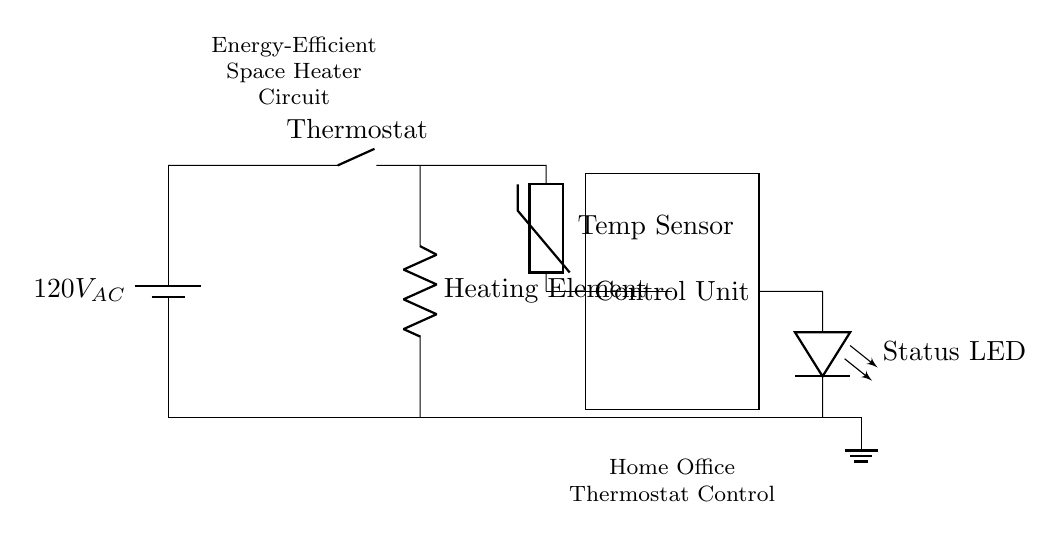What is the main power supply voltage of this circuit? The power supply voltage is indicated as 120V AC, which is explicitly shown at the start of the circuit diagram.
Answer: 120V AC What component acts as the control mechanism in this circuit? The control mechanism in this circuit is the control unit, which is a rectangular box labeled "Control Unit" connected to other components for regulating the heater's operation.
Answer: Control Unit What is the function of the thermistor in the circuit? The thermistor serves as a temperature sensor, measuring the ambient temperature and providing input to the control unit based on that measurement to regulate the heating element.
Answer: Temperature sensor How is the heating element connected in the circuit? The heating element is connected in series to the power supply and the thermostat, indicating that it is involved in the direct heating of the space once the thermostat allows current to flow.
Answer: In series with the power supply and thermostat What type of indicator is used in this circuit? The indicator used in this circuit is an LED, which is represented in the diagram as "Status LED". It shows the operational status of the space heater.
Answer: LED Which component is responsible for executing the heating regulation based on temperature? The component responsible for executing the heating regulation based on temperature is the control unit, as it receives input from the thermistor and manages the operation of the heating element accordingly.
Answer: Control Unit Is the circuit intended for energy efficiency? Yes, the circuit is specifically labeled as an "Energy-Efficient Space Heater Circuit", indicating that it is designed to minimize energy consumption while providing heating.
Answer: Yes 